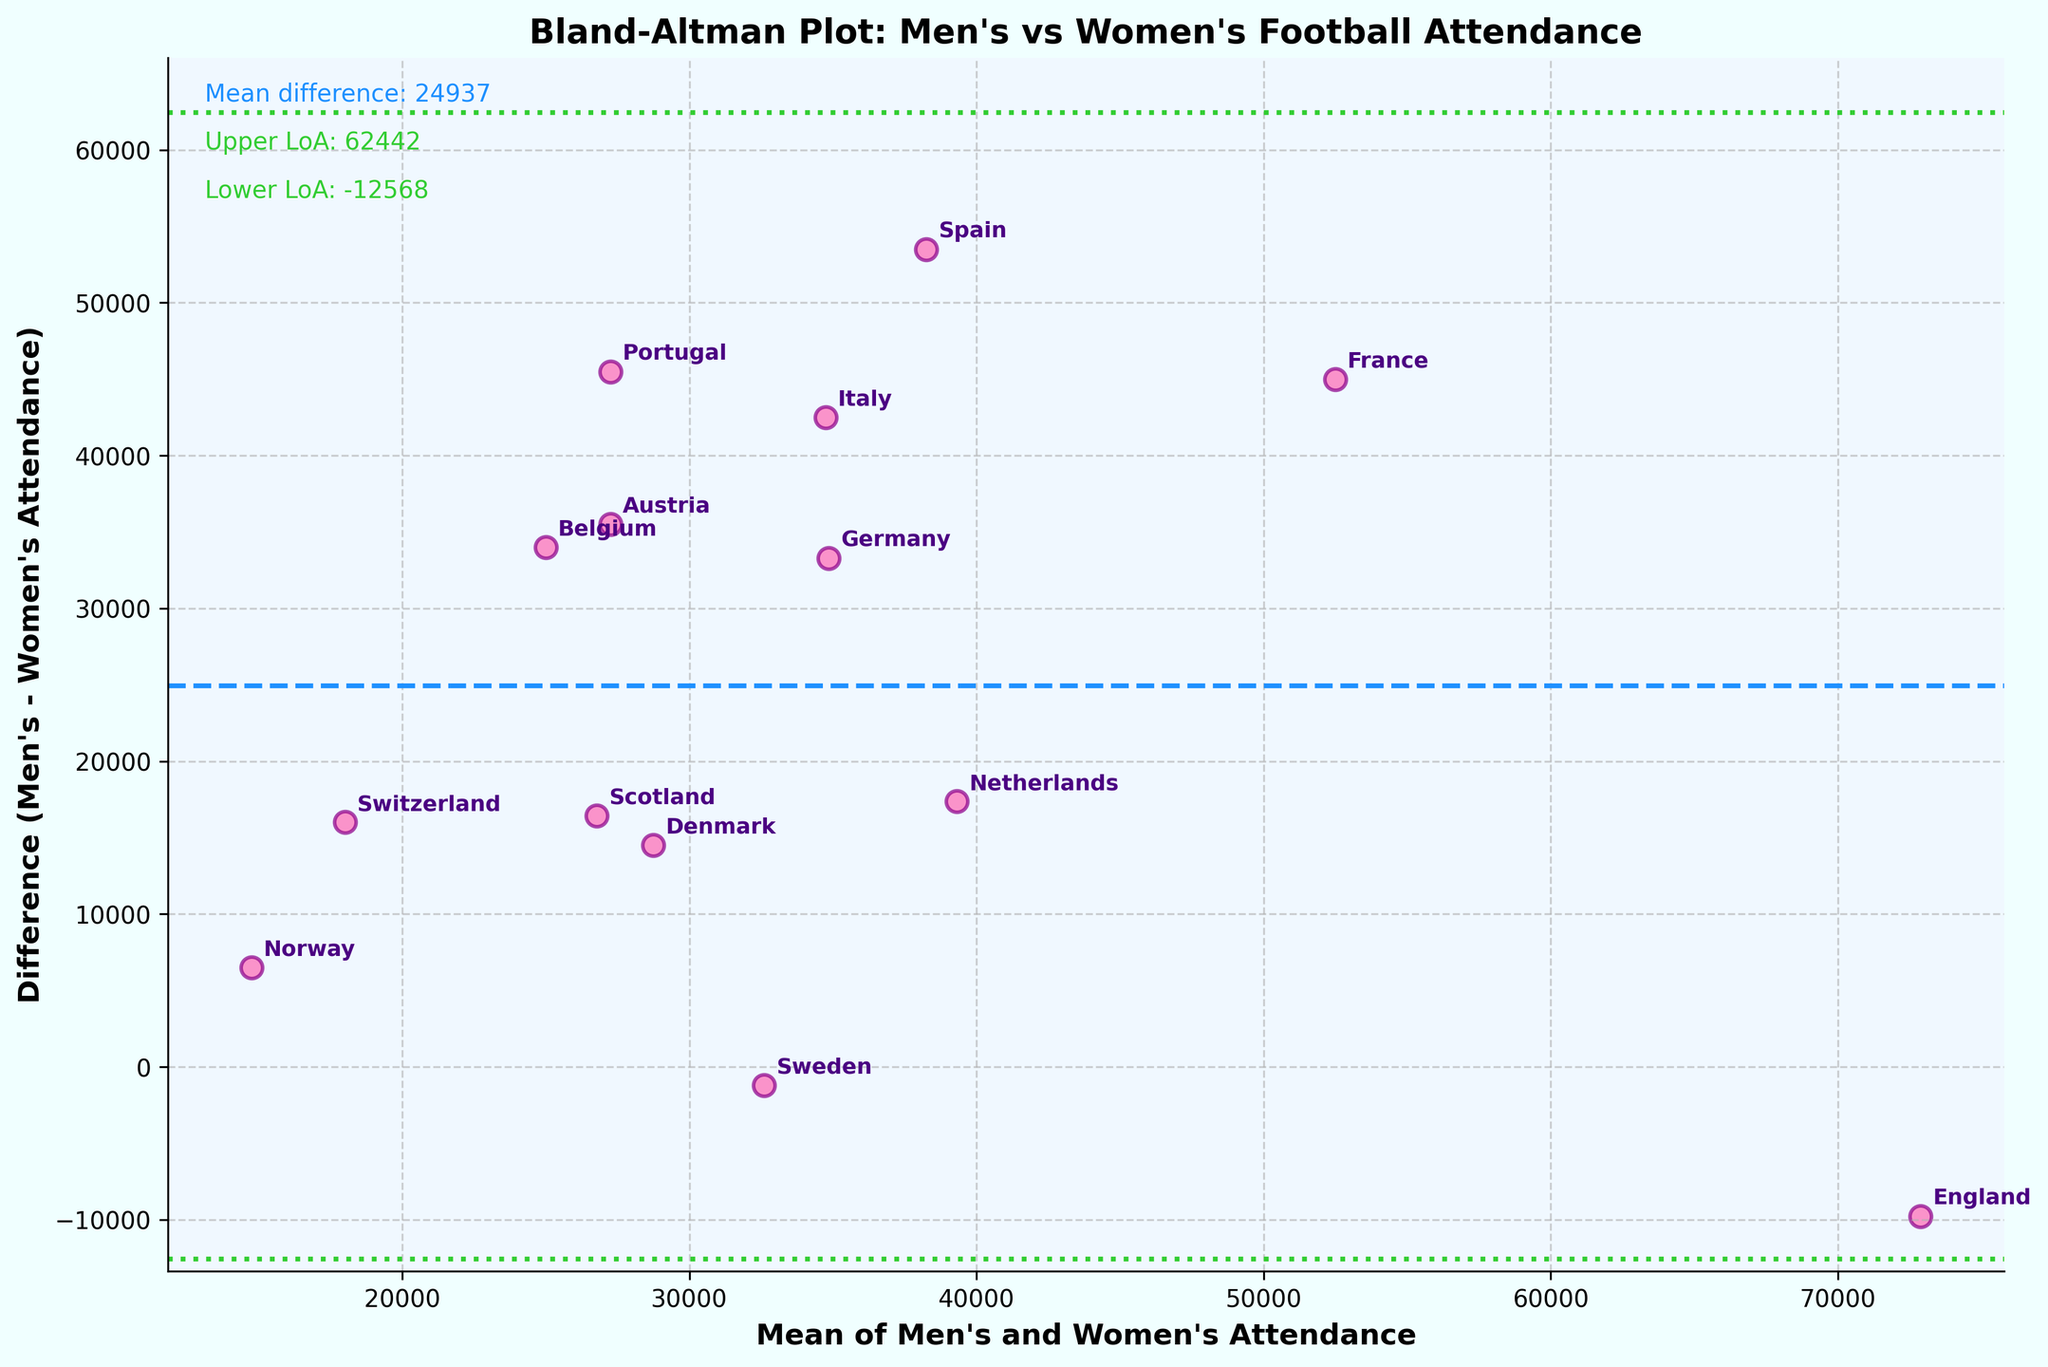What is the title of the plot? The title of the plot is displayed at the top and reads "Bland-Altman Plot: Men's vs Women's Football Attendance". Therefore, look at the title to find it.
Answer: Bland-Altman Plot: Men's vs Women's Football Attendance What does the x-axis represent? The x-axis is labeled "Mean of Men's and Women's Attendance," indicating that it represents the average of the attendance figures for men's and women's national team matches.
Answer: Mean of Men's and Women's Attendance Which country has the highest difference in attendance between men's and women's matches? By observing the plot, the country with the largest vertical distance from zero on the y-axis (which represents the difference) is France.
Answer: France What's the mean difference of men's and women's attendance? The mean difference is displayed as text on the left side of the plot and is represented by a dashed blue line. The value is given alongside the text "Mean difference".
Answer: 28375 Which country's average attendance is closest to 30,000? By locating the data points near 30,000 on the x-axis, Denmark appears to be the closest country where the average attendance is around this value.
Answer: Denmark What are the limits of agreement for this plot? The limits of agreement are shown by dotted green lines. They are also written as text in the upper left corner of the plot with "Upper LoA" and "Lower LoA" labels.
Answer: 61448, -4698 What is the y-axis value for Germany? To find this, locate Germany on the plot and see its y-axis value. It appears around 33,300.
Answer: 33,300 How does the attendance difference for women compared to men vary across countries? In most cases, men's attendance is higher than women's, as indicated by most points being above zero on the y-axis. Additionally, there are a few countries where women's attendance exceeds men's, seen in points below the zero line.
Answer: Men's > Women's Which countries have similar attendance figures for men’s and women's matches? Countries closest to the y-axis value of zero on the plot have similar attendance figures. Sweden is an example where the difference is minimal.
Answer: Sweden Which country has the smallest mean attendance for both men's and women's matches? By checking the far left side of the x-axis values, Norway has the smallest mean attendance.
Answer: Norway 